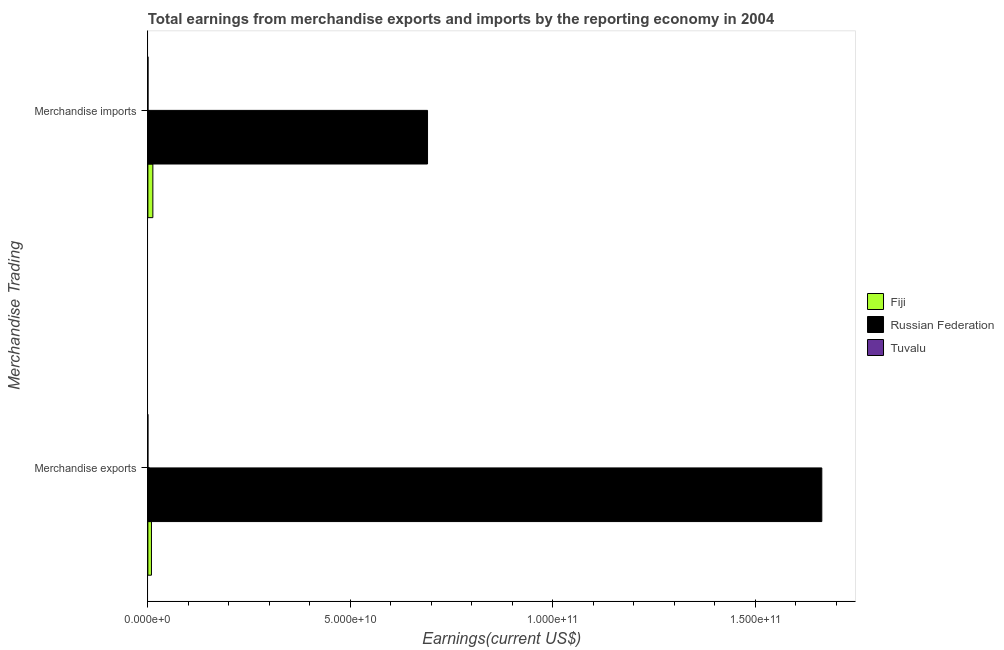How many different coloured bars are there?
Make the answer very short. 3. Are the number of bars per tick equal to the number of legend labels?
Provide a succinct answer. Yes. How many bars are there on the 2nd tick from the top?
Your answer should be very brief. 3. What is the label of the 2nd group of bars from the top?
Keep it short and to the point. Merchandise exports. What is the earnings from merchandise imports in Russian Federation?
Provide a short and direct response. 6.91e+1. Across all countries, what is the maximum earnings from merchandise imports?
Your answer should be compact. 6.91e+1. Across all countries, what is the minimum earnings from merchandise imports?
Offer a very short reply. 3.09e+07. In which country was the earnings from merchandise imports maximum?
Offer a terse response. Russian Federation. In which country was the earnings from merchandise exports minimum?
Provide a short and direct response. Tuvalu. What is the total earnings from merchandise exports in the graph?
Give a very brief answer. 1.67e+11. What is the difference between the earnings from merchandise imports in Fiji and that in Russian Federation?
Provide a short and direct response. -6.78e+1. What is the difference between the earnings from merchandise imports in Russian Federation and the earnings from merchandise exports in Fiji?
Make the answer very short. 6.82e+1. What is the average earnings from merchandise imports per country?
Give a very brief answer. 2.34e+1. What is the difference between the earnings from merchandise imports and earnings from merchandise exports in Russian Federation?
Keep it short and to the point. -9.74e+1. What is the ratio of the earnings from merchandise imports in Russian Federation to that in Tuvalu?
Provide a short and direct response. 2237.73. Is the earnings from merchandise exports in Fiji less than that in Tuvalu?
Give a very brief answer. No. What does the 2nd bar from the top in Merchandise exports represents?
Your answer should be compact. Russian Federation. What does the 2nd bar from the bottom in Merchandise imports represents?
Your answer should be very brief. Russian Federation. What is the difference between two consecutive major ticks on the X-axis?
Keep it short and to the point. 5.00e+1. Are the values on the major ticks of X-axis written in scientific E-notation?
Keep it short and to the point. Yes. Does the graph contain any zero values?
Offer a very short reply. No. Does the graph contain grids?
Provide a short and direct response. No. Where does the legend appear in the graph?
Ensure brevity in your answer.  Center right. How are the legend labels stacked?
Give a very brief answer. Vertical. What is the title of the graph?
Make the answer very short. Total earnings from merchandise exports and imports by the reporting economy in 2004. Does "Austria" appear as one of the legend labels in the graph?
Provide a short and direct response. No. What is the label or title of the X-axis?
Give a very brief answer. Earnings(current US$). What is the label or title of the Y-axis?
Your answer should be very brief. Merchandise Trading. What is the Earnings(current US$) in Fiji in Merchandise exports?
Offer a very short reply. 8.84e+08. What is the Earnings(current US$) of Russian Federation in Merchandise exports?
Provide a succinct answer. 1.66e+11. What is the Earnings(current US$) in Tuvalu in Merchandise exports?
Your response must be concise. 1.14e+06. What is the Earnings(current US$) of Fiji in Merchandise imports?
Ensure brevity in your answer.  1.23e+09. What is the Earnings(current US$) of Russian Federation in Merchandise imports?
Ensure brevity in your answer.  6.91e+1. What is the Earnings(current US$) of Tuvalu in Merchandise imports?
Offer a terse response. 3.09e+07. Across all Merchandise Trading, what is the maximum Earnings(current US$) of Fiji?
Provide a short and direct response. 1.23e+09. Across all Merchandise Trading, what is the maximum Earnings(current US$) in Russian Federation?
Give a very brief answer. 1.66e+11. Across all Merchandise Trading, what is the maximum Earnings(current US$) of Tuvalu?
Offer a very short reply. 3.09e+07. Across all Merchandise Trading, what is the minimum Earnings(current US$) in Fiji?
Make the answer very short. 8.84e+08. Across all Merchandise Trading, what is the minimum Earnings(current US$) in Russian Federation?
Keep it short and to the point. 6.91e+1. Across all Merchandise Trading, what is the minimum Earnings(current US$) in Tuvalu?
Keep it short and to the point. 1.14e+06. What is the total Earnings(current US$) of Fiji in the graph?
Provide a succinct answer. 2.12e+09. What is the total Earnings(current US$) in Russian Federation in the graph?
Provide a short and direct response. 2.35e+11. What is the total Earnings(current US$) of Tuvalu in the graph?
Offer a very short reply. 3.20e+07. What is the difference between the Earnings(current US$) in Fiji in Merchandise exports and that in Merchandise imports?
Ensure brevity in your answer.  -3.47e+08. What is the difference between the Earnings(current US$) in Russian Federation in Merchandise exports and that in Merchandise imports?
Keep it short and to the point. 9.74e+1. What is the difference between the Earnings(current US$) in Tuvalu in Merchandise exports and that in Merchandise imports?
Your answer should be compact. -2.97e+07. What is the difference between the Earnings(current US$) in Fiji in Merchandise exports and the Earnings(current US$) in Russian Federation in Merchandise imports?
Your response must be concise. -6.82e+1. What is the difference between the Earnings(current US$) of Fiji in Merchandise exports and the Earnings(current US$) of Tuvalu in Merchandise imports?
Offer a very short reply. 8.53e+08. What is the difference between the Earnings(current US$) in Russian Federation in Merchandise exports and the Earnings(current US$) in Tuvalu in Merchandise imports?
Your response must be concise. 1.66e+11. What is the average Earnings(current US$) of Fiji per Merchandise Trading?
Provide a short and direct response. 1.06e+09. What is the average Earnings(current US$) in Russian Federation per Merchandise Trading?
Give a very brief answer. 1.18e+11. What is the average Earnings(current US$) in Tuvalu per Merchandise Trading?
Ensure brevity in your answer.  1.60e+07. What is the difference between the Earnings(current US$) in Fiji and Earnings(current US$) in Russian Federation in Merchandise exports?
Provide a short and direct response. -1.66e+11. What is the difference between the Earnings(current US$) in Fiji and Earnings(current US$) in Tuvalu in Merchandise exports?
Keep it short and to the point. 8.83e+08. What is the difference between the Earnings(current US$) in Russian Federation and Earnings(current US$) in Tuvalu in Merchandise exports?
Give a very brief answer. 1.66e+11. What is the difference between the Earnings(current US$) in Fiji and Earnings(current US$) in Russian Federation in Merchandise imports?
Provide a short and direct response. -6.78e+1. What is the difference between the Earnings(current US$) in Fiji and Earnings(current US$) in Tuvalu in Merchandise imports?
Your answer should be compact. 1.20e+09. What is the difference between the Earnings(current US$) of Russian Federation and Earnings(current US$) of Tuvalu in Merchandise imports?
Your answer should be compact. 6.90e+1. What is the ratio of the Earnings(current US$) of Fiji in Merchandise exports to that in Merchandise imports?
Provide a succinct answer. 0.72. What is the ratio of the Earnings(current US$) in Russian Federation in Merchandise exports to that in Merchandise imports?
Ensure brevity in your answer.  2.41. What is the ratio of the Earnings(current US$) of Tuvalu in Merchandise exports to that in Merchandise imports?
Make the answer very short. 0.04. What is the difference between the highest and the second highest Earnings(current US$) of Fiji?
Your answer should be very brief. 3.47e+08. What is the difference between the highest and the second highest Earnings(current US$) in Russian Federation?
Your answer should be very brief. 9.74e+1. What is the difference between the highest and the second highest Earnings(current US$) in Tuvalu?
Provide a succinct answer. 2.97e+07. What is the difference between the highest and the lowest Earnings(current US$) of Fiji?
Offer a very short reply. 3.47e+08. What is the difference between the highest and the lowest Earnings(current US$) in Russian Federation?
Give a very brief answer. 9.74e+1. What is the difference between the highest and the lowest Earnings(current US$) of Tuvalu?
Make the answer very short. 2.97e+07. 